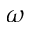Convert formula to latex. <formula><loc_0><loc_0><loc_500><loc_500>\omega</formula> 